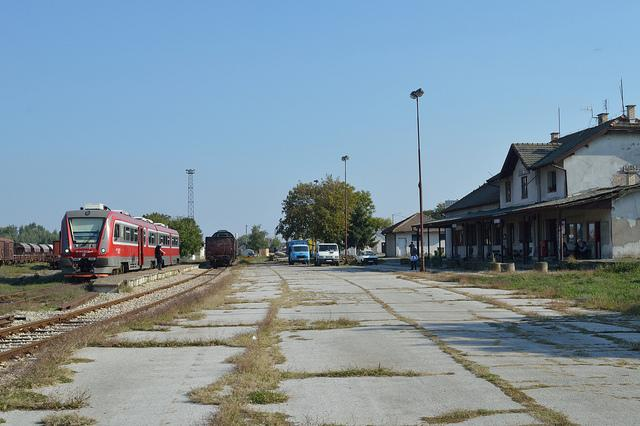What is the old rusted freight car in the background probably used to carry? Please explain your reasoning. coal. The car has coal. 